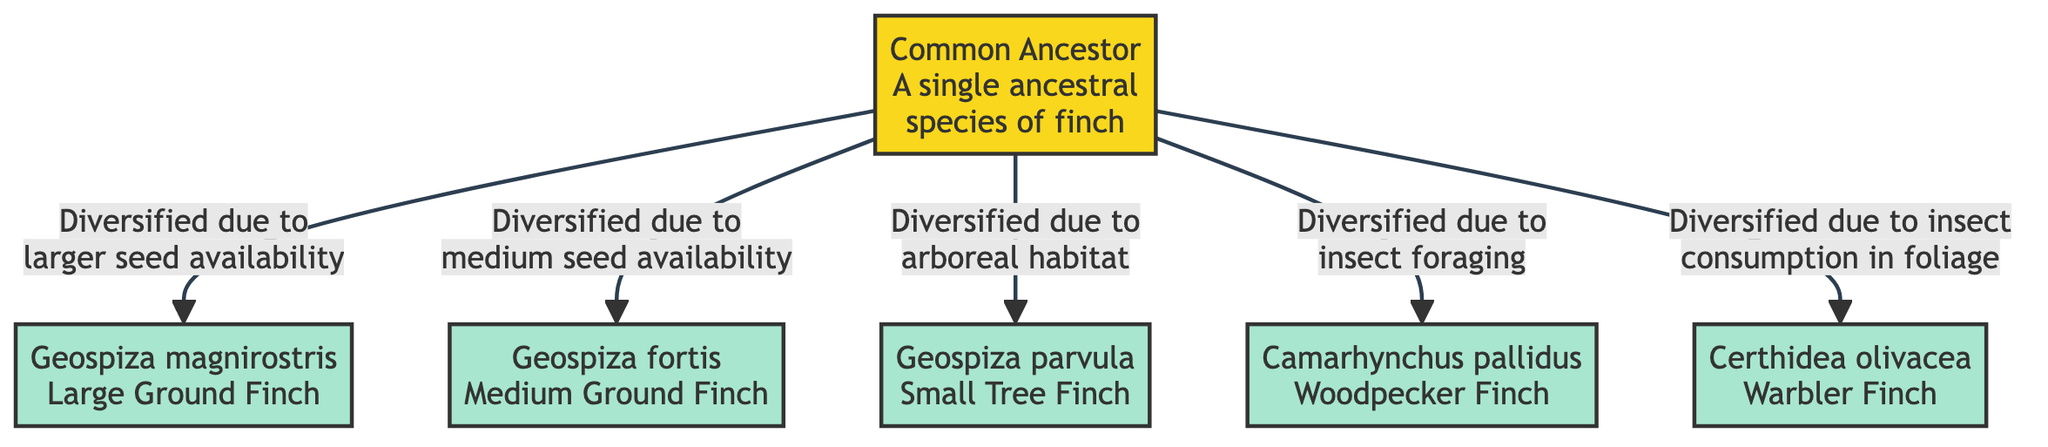What is the common ancestor species of the finches? The diagram explicitly labels the common ancestor as "A single ancestral species of finch," which is referred to as the Common Ancestor (CA).
Answer: Common Ancestor How many species are derived from the common ancestor? The diagram shows five species deriving from the common ancestor (GM, GF, GP, CP, CO), which can be counted directly from the arrows pointing away from the Common Ancestor (CA).
Answer: Five Which species diversified due to larger seed availability? The diagram shows an arrow from the common ancestor pointing to Geospiza magnirostris (GM), with the annotation stating "Diversified due to larger seed availability," which indicates GM's relation to this factor.
Answer: Geospiza magnirostris What environmental factor led to the diversification of the Woodpecker Finch? According to the diagram, the arrow leading to Camarhynchus pallidus (CP) is annotated with "Diversified due to insect foraging,” indicating this specific environmental factor.
Answer: Insect foraging Which species are labeled as tree finches? The diagram includes Geospiza parvula (GP), which has the annotation with "arboreal habitat," making it a tree finch subtype, confirming GP's classification as a tree finch.
Answer: Geospiza parvula What is the relationship between the Common Ancestor and the Medium Ground Finch? The diagram indicates a direct connection from the Common Ancestor (CA) to Geospiza fortis (GF), annotated with "Diversified due to medium seed availability," establishing the relationship based on environmental factors.
Answer: Direct connection Which species is associated with insect consumption in foliage? The diagram shows that Certhidea olivacea (CO) is indicated through the annotation "Diversified due to insect consumption in foliage," directly linking CO to this specific foraging behavior.
Answer: Certhidea olivacea How many arrows are shown in the diagram? By counting the arrows present in the diagram, which represent diversification paths, we find there are five individual arrows indicating the derived species from the common ancestor.
Answer: Five What color represents the common ancestor in the diagram? The diagram uses a specific fill color for the common ancestor class, indicated as "#f9d71c," designating it with a yellowish hue.
Answer: Yellow 